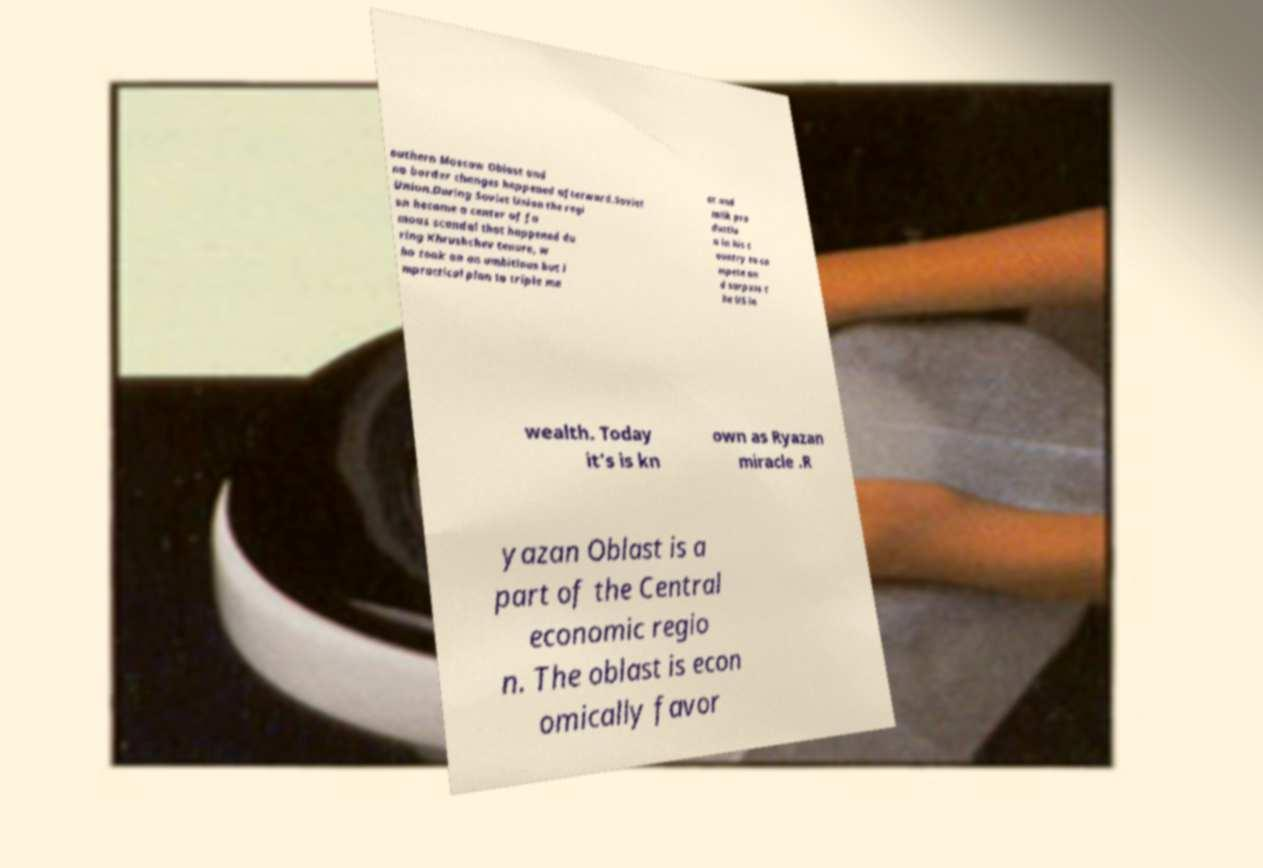I need the written content from this picture converted into text. Can you do that? outhern Moscow Oblast and no border changes happened afterward.Soviet Union.During Soviet Union the regi on became a center of fa mous scandal that happened du ring Khrushchev tenure, w ho took on an ambitious but i mpractical plan to triple me at and milk pro ductio n in his c ountry to co mpete an d surpass t he US in wealth. Today it's is kn own as Ryazan miracle .R yazan Oblast is a part of the Central economic regio n. The oblast is econ omically favor 